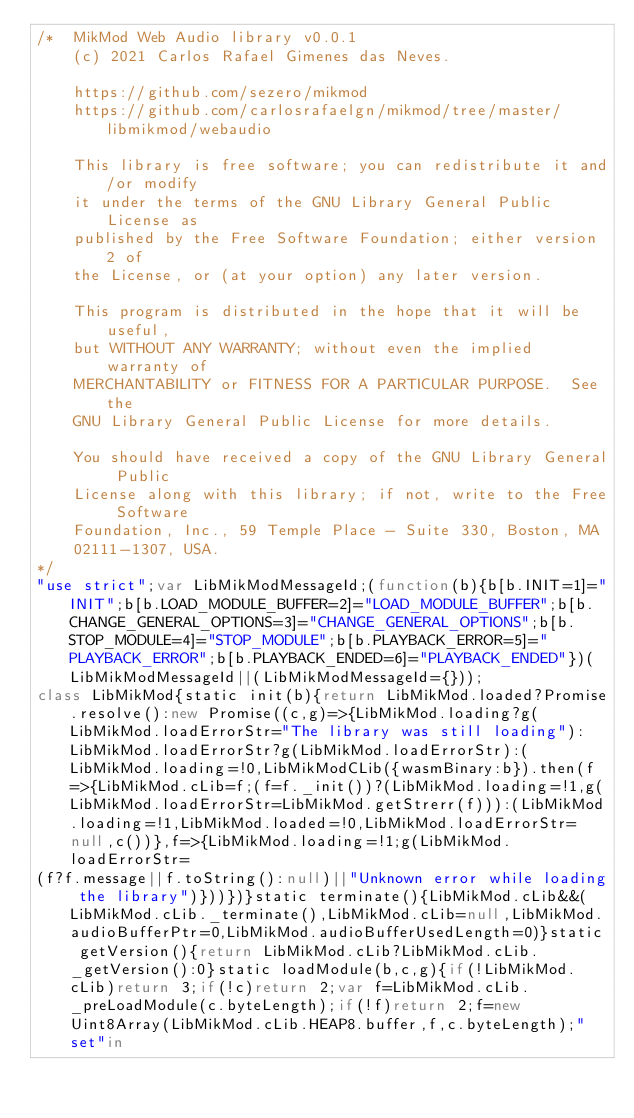Convert code to text. <code><loc_0><loc_0><loc_500><loc_500><_JavaScript_>/*	MikMod Web Audio library v0.0.1
	(c) 2021 Carlos Rafael Gimenes das Neves.

	https://github.com/sezero/mikmod
	https://github.com/carlosrafaelgn/mikmod/tree/master/libmikmod/webaudio

	This library is free software; you can redistribute it and/or modify
	it under the terms of the GNU Library General Public License as
	published by the Free Software Foundation; either version 2 of
	the License, or (at your option) any later version.

	This program is distributed in the hope that it will be useful,
	but WITHOUT ANY WARRANTY; without even the implied warranty of
	MERCHANTABILITY or FITNESS FOR A PARTICULAR PURPOSE.  See the
	GNU Library General Public License for more details.

	You should have received a copy of the GNU Library General Public
	License along with this library; if not, write to the Free Software
	Foundation, Inc., 59 Temple Place - Suite 330, Boston, MA
	02111-1307, USA.
*/
"use strict";var LibMikModMessageId;(function(b){b[b.INIT=1]="INIT";b[b.LOAD_MODULE_BUFFER=2]="LOAD_MODULE_BUFFER";b[b.CHANGE_GENERAL_OPTIONS=3]="CHANGE_GENERAL_OPTIONS";b[b.STOP_MODULE=4]="STOP_MODULE";b[b.PLAYBACK_ERROR=5]="PLAYBACK_ERROR";b[b.PLAYBACK_ENDED=6]="PLAYBACK_ENDED"})(LibMikModMessageId||(LibMikModMessageId={}));
class LibMikMod{static init(b){return LibMikMod.loaded?Promise.resolve():new Promise((c,g)=>{LibMikMod.loading?g(LibMikMod.loadErrorStr="The library was still loading"):LibMikMod.loadErrorStr?g(LibMikMod.loadErrorStr):(LibMikMod.loading=!0,LibMikModCLib({wasmBinary:b}).then(f=>{LibMikMod.cLib=f;(f=f._init())?(LibMikMod.loading=!1,g(LibMikMod.loadErrorStr=LibMikMod.getStrerr(f))):(LibMikMod.loading=!1,LibMikMod.loaded=!0,LibMikMod.loadErrorStr=null,c())},f=>{LibMikMod.loading=!1;g(LibMikMod.loadErrorStr=
(f?f.message||f.toString():null)||"Unknown error while loading the library")}))})}static terminate(){LibMikMod.cLib&&(LibMikMod.cLib._terminate(),LibMikMod.cLib=null,LibMikMod.audioBufferPtr=0,LibMikMod.audioBufferUsedLength=0)}static getVersion(){return LibMikMod.cLib?LibMikMod.cLib._getVersion():0}static loadModule(b,c,g){if(!LibMikMod.cLib)return 3;if(!c)return 2;var f=LibMikMod.cLib._preLoadModule(c.byteLength);if(!f)return 2;f=new Uint8Array(LibMikMod.cLib.HEAP8.buffer,f,c.byteLength);"set"in</code> 